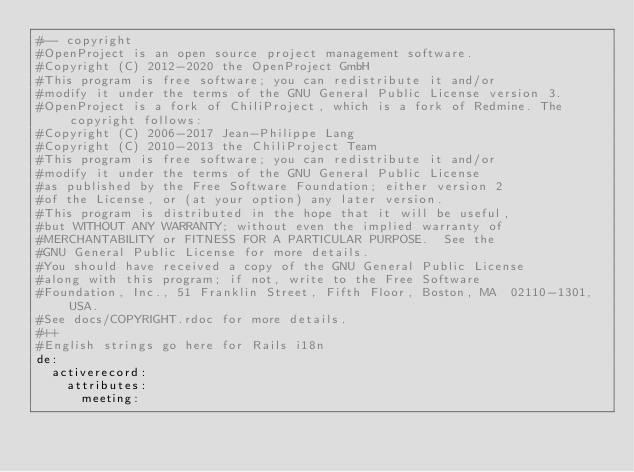<code> <loc_0><loc_0><loc_500><loc_500><_YAML_>#-- copyright
#OpenProject is an open source project management software.
#Copyright (C) 2012-2020 the OpenProject GmbH
#This program is free software; you can redistribute it and/or
#modify it under the terms of the GNU General Public License version 3.
#OpenProject is a fork of ChiliProject, which is a fork of Redmine. The copyright follows:
#Copyright (C) 2006-2017 Jean-Philippe Lang
#Copyright (C) 2010-2013 the ChiliProject Team
#This program is free software; you can redistribute it and/or
#modify it under the terms of the GNU General Public License
#as published by the Free Software Foundation; either version 2
#of the License, or (at your option) any later version.
#This program is distributed in the hope that it will be useful,
#but WITHOUT ANY WARRANTY; without even the implied warranty of
#MERCHANTABILITY or FITNESS FOR A PARTICULAR PURPOSE.  See the
#GNU General Public License for more details.
#You should have received a copy of the GNU General Public License
#along with this program; if not, write to the Free Software
#Foundation, Inc., 51 Franklin Street, Fifth Floor, Boston, MA  02110-1301, USA.
#See docs/COPYRIGHT.rdoc for more details.
#++
#English strings go here for Rails i18n
de:
  activerecord:
    attributes:
      meeting:</code> 